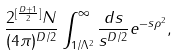Convert formula to latex. <formula><loc_0><loc_0><loc_500><loc_500>\frac { 2 ^ { [ \frac { D + 1 } { 2 } ] } N } { ( 4 \pi ) ^ { D / 2 } } \int ^ { \infty } _ { 1 / \Lambda ^ { 2 } } \frac { d s } { s ^ { D / 2 } } e ^ { - s \rho ^ { 2 } } ,</formula> 